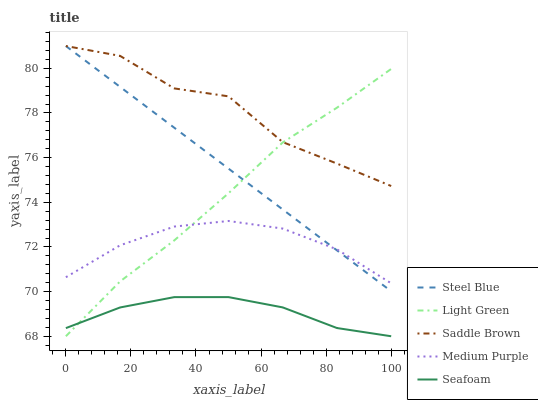Does Seafoam have the minimum area under the curve?
Answer yes or no. Yes. Does Saddle Brown have the maximum area under the curve?
Answer yes or no. Yes. Does Steel Blue have the minimum area under the curve?
Answer yes or no. No. Does Steel Blue have the maximum area under the curve?
Answer yes or no. No. Is Steel Blue the smoothest?
Answer yes or no. Yes. Is Saddle Brown the roughest?
Answer yes or no. Yes. Is Seafoam the smoothest?
Answer yes or no. No. Is Seafoam the roughest?
Answer yes or no. No. Does Seafoam have the lowest value?
Answer yes or no. Yes. Does Steel Blue have the lowest value?
Answer yes or no. No. Does Saddle Brown have the highest value?
Answer yes or no. Yes. Does Seafoam have the highest value?
Answer yes or no. No. Is Seafoam less than Steel Blue?
Answer yes or no. Yes. Is Medium Purple greater than Seafoam?
Answer yes or no. Yes. Does Saddle Brown intersect Steel Blue?
Answer yes or no. Yes. Is Saddle Brown less than Steel Blue?
Answer yes or no. No. Is Saddle Brown greater than Steel Blue?
Answer yes or no. No. Does Seafoam intersect Steel Blue?
Answer yes or no. No. 